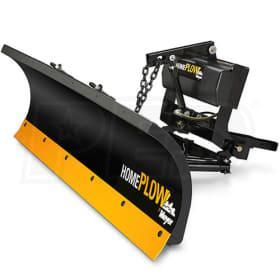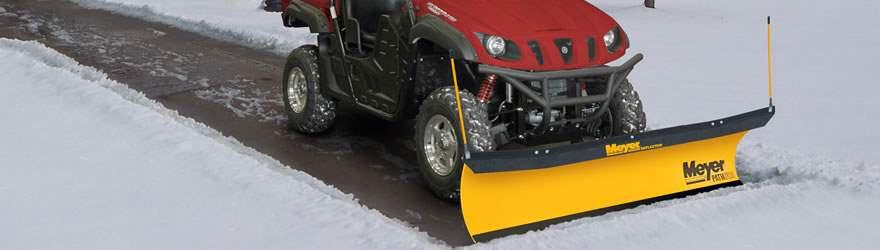The first image is the image on the left, the second image is the image on the right. Given the left and right images, does the statement "At least one snowplow is not yellow." hold true? Answer yes or no. No. 